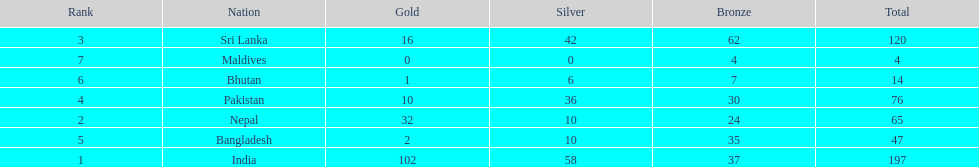What country has won no silver medals? Maldives. 